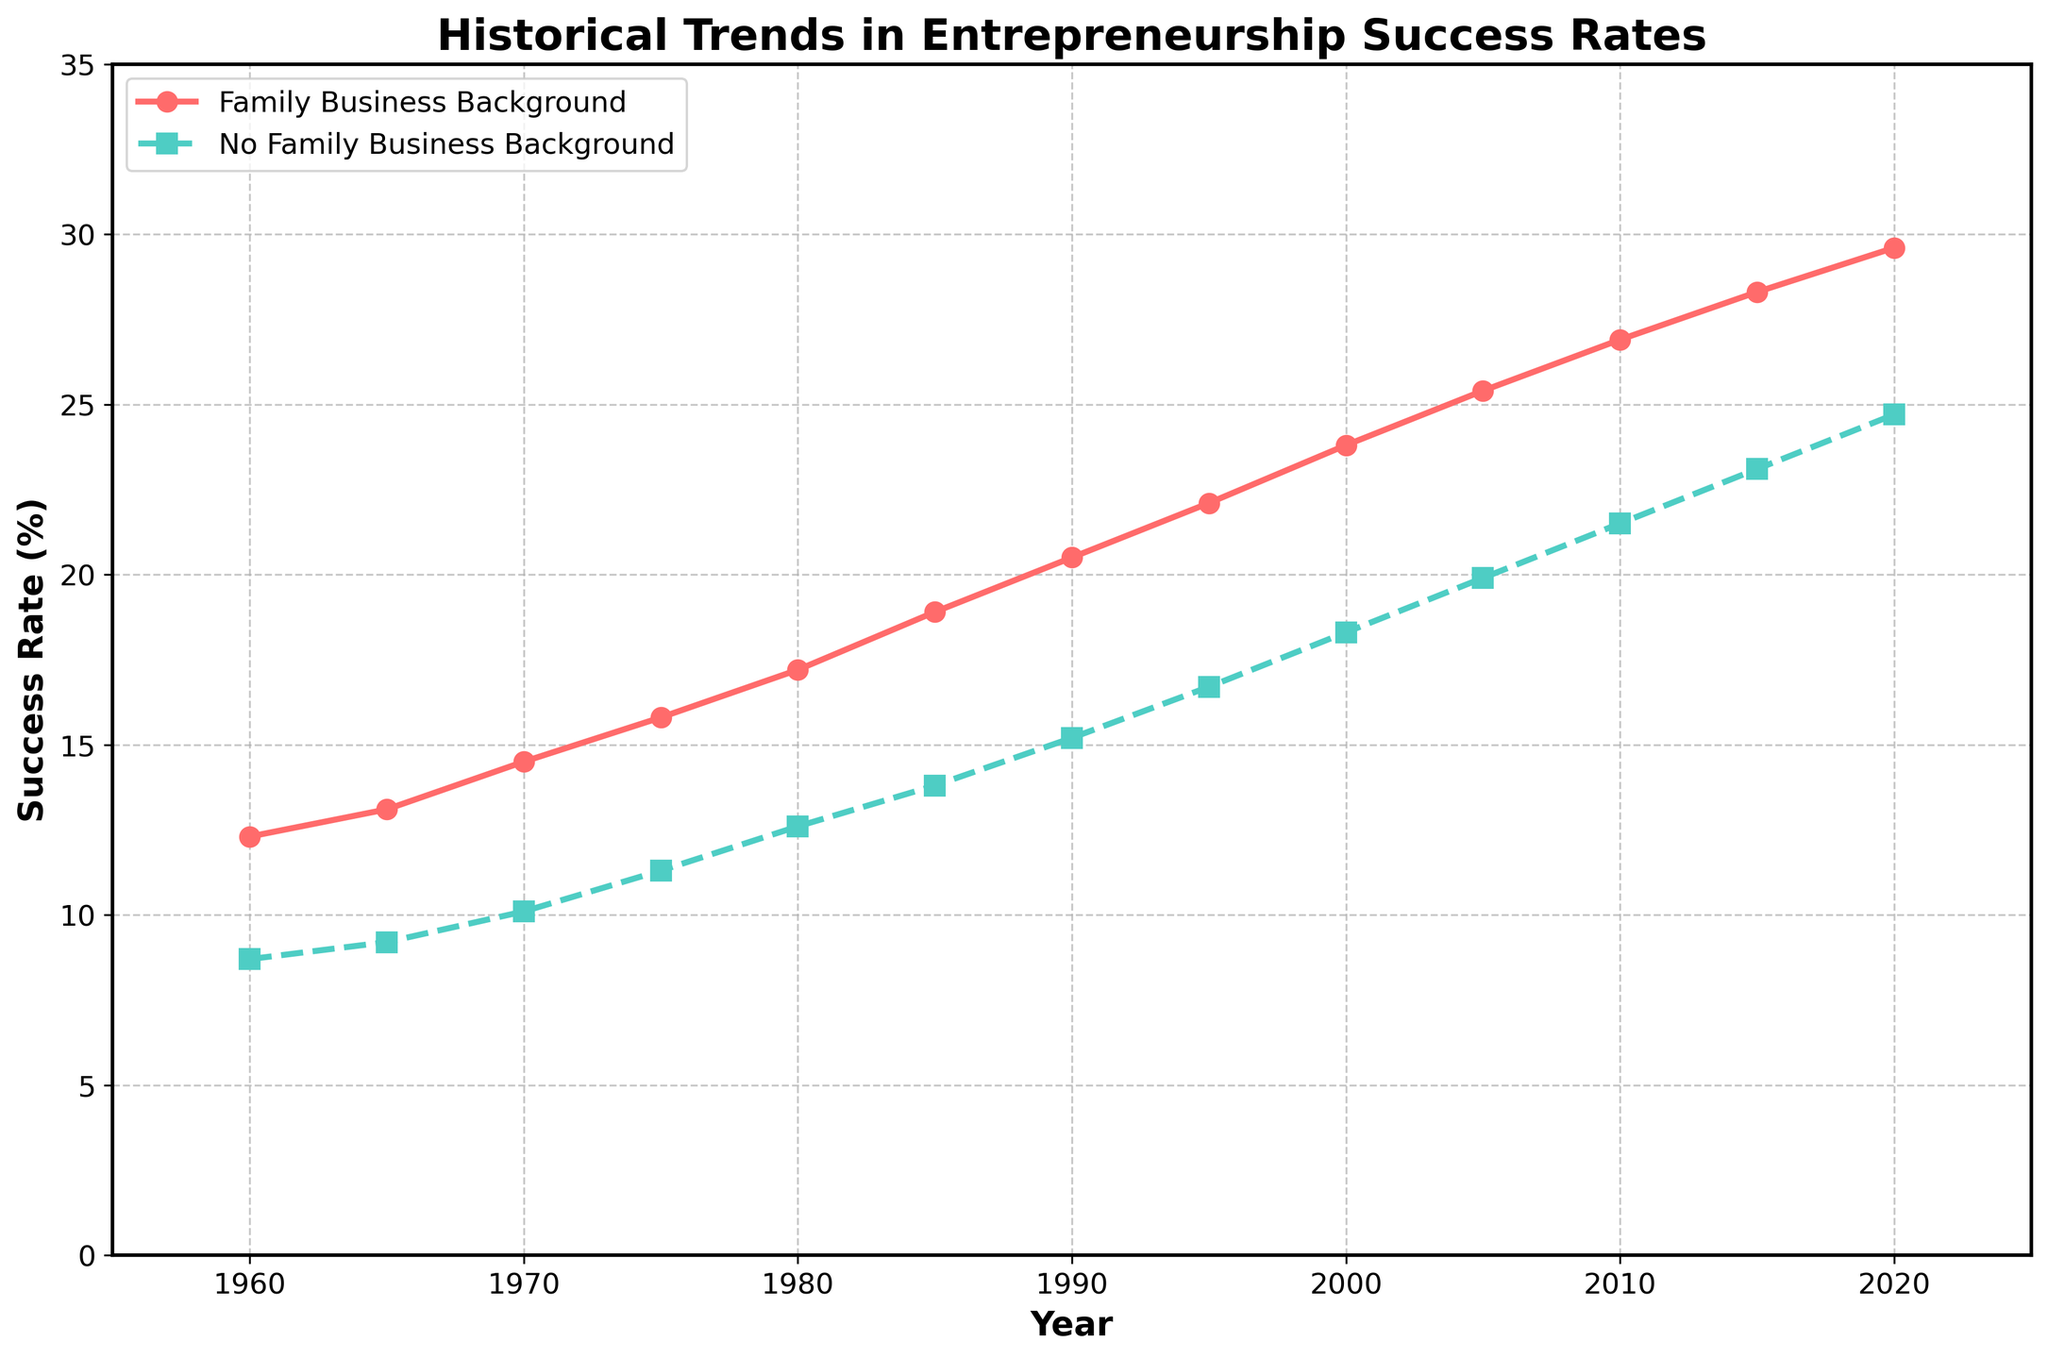What's the difference in entrepreneurship success rates between individuals with a family business background and those without in 1980? The success rate for individuals with a family business background in 1980 is 17.2%, and for those without is 12.6%. The difference is 17.2 - 12.6 = 4.6%
Answer: 4.6% Between 1960 and 2020, which group showed a greater increase in entrepreneurship success rates? Individuals with a family business background increased from 12.3% in 1960 to 29.6% in 2020, an increase of 29.6 - 12.3 = 17.3%. Those without a family business background increased from 8.7% to 24.7%, an increase of 24.7 - 8.7 = 16.0%. The group with a family business background showed a greater increase.
Answer: Family Business Background What is the average entrepreneurship success rate for individuals with no family business background from 1990 to 2000? The success rates for individuals with no family business background are 15.2% (1990), 16.7% (1995), and 18.3% (2000). The average is (15.2 + 16.7 + 18.3) / 3 = 50.2 / 3 = 16.73%
Answer: 16.73% In which year did both groups experience their first double-digit success rates? Individuals with a family business background exceeded 10% in 1970 (14.5%), and those without a family business background also in 1970 (10.1%). Thus, 1970 is the first year both groups had double-digit success rates.
Answer: 1970 Compare the slope (rate of increase) of entrepreneurship success rates between the two groups from 2000 to 2015. Which group's rate of increase was higher? The increase for individuals with a family business background from 2000 to 2015 is 28.3 - 23.8 = 4.5%. For those without a family business background, it is 23.1 - 18.3 = 4.8%. The rate of increase is higher for those without a family business background.
Answer: No Family Business Background How does the gap in success rates between the two groups change from 1960 to 2020? The gap in 1960 is 12.3 - 8.7 = 3.6%. In 2020, the gap is 29.6 - 24.7 = 4.9%. Thus, the gap increased from 3.6% to 4.9%.
Answer: Increased by 1.3% What color line represents individuals with no family business background in the plot? The line representing individuals with no family business background is described as having a marker 's' and being dashed, with the color described as '#4ECDC4'. This corresponds to green.
Answer: Green During which 10-year period did individuals with family business backgrounds experience the largest absolute rise in success rates? The success rates increase for individuals with family business backgrounds as follows: 1960-1970 (14.5 - 12.3 = 2.2), 1970-1980 (17.2 - 14.5 = 2.7), 1980-1990 (20.5 - 17.2 = 3.3), 1990-2000 (23.8 - 20.5 = 3.3), 2000-2010 (26.9 - 23.8 = 3.1), and 2010-2020 (29.6 - 26.9 = 2.7). The largest rise occurred between 1980 and 2000, both periods showing a rise of 3.3%.
Answer: 1980-2000 